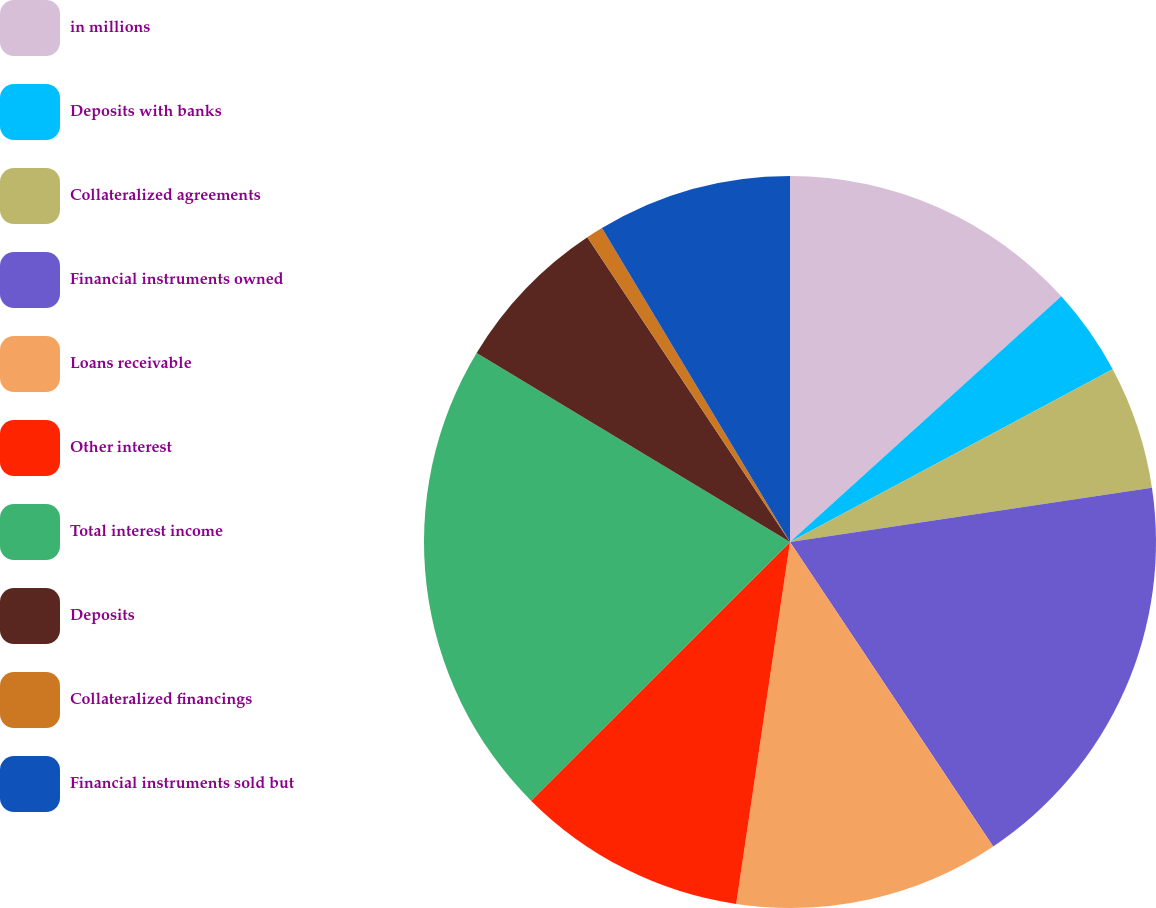Convert chart to OTSL. <chart><loc_0><loc_0><loc_500><loc_500><pie_chart><fcel>in millions<fcel>Deposits with banks<fcel>Collateralized agreements<fcel>Financial instruments owned<fcel>Loans receivable<fcel>Other interest<fcel>Total interest income<fcel>Deposits<fcel>Collateralized financings<fcel>Financial instruments sold but<nl><fcel>13.29%<fcel>3.89%<fcel>5.45%<fcel>18.0%<fcel>11.72%<fcel>10.16%<fcel>21.13%<fcel>7.02%<fcel>0.75%<fcel>8.59%<nl></chart> 